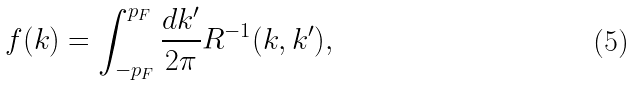<formula> <loc_0><loc_0><loc_500><loc_500>f ( k ) = \int _ { - p _ { F } } ^ { p _ { F } } \frac { d k ^ { \prime } } { 2 \pi } R ^ { - 1 } ( k , k ^ { \prime } ) ,</formula> 